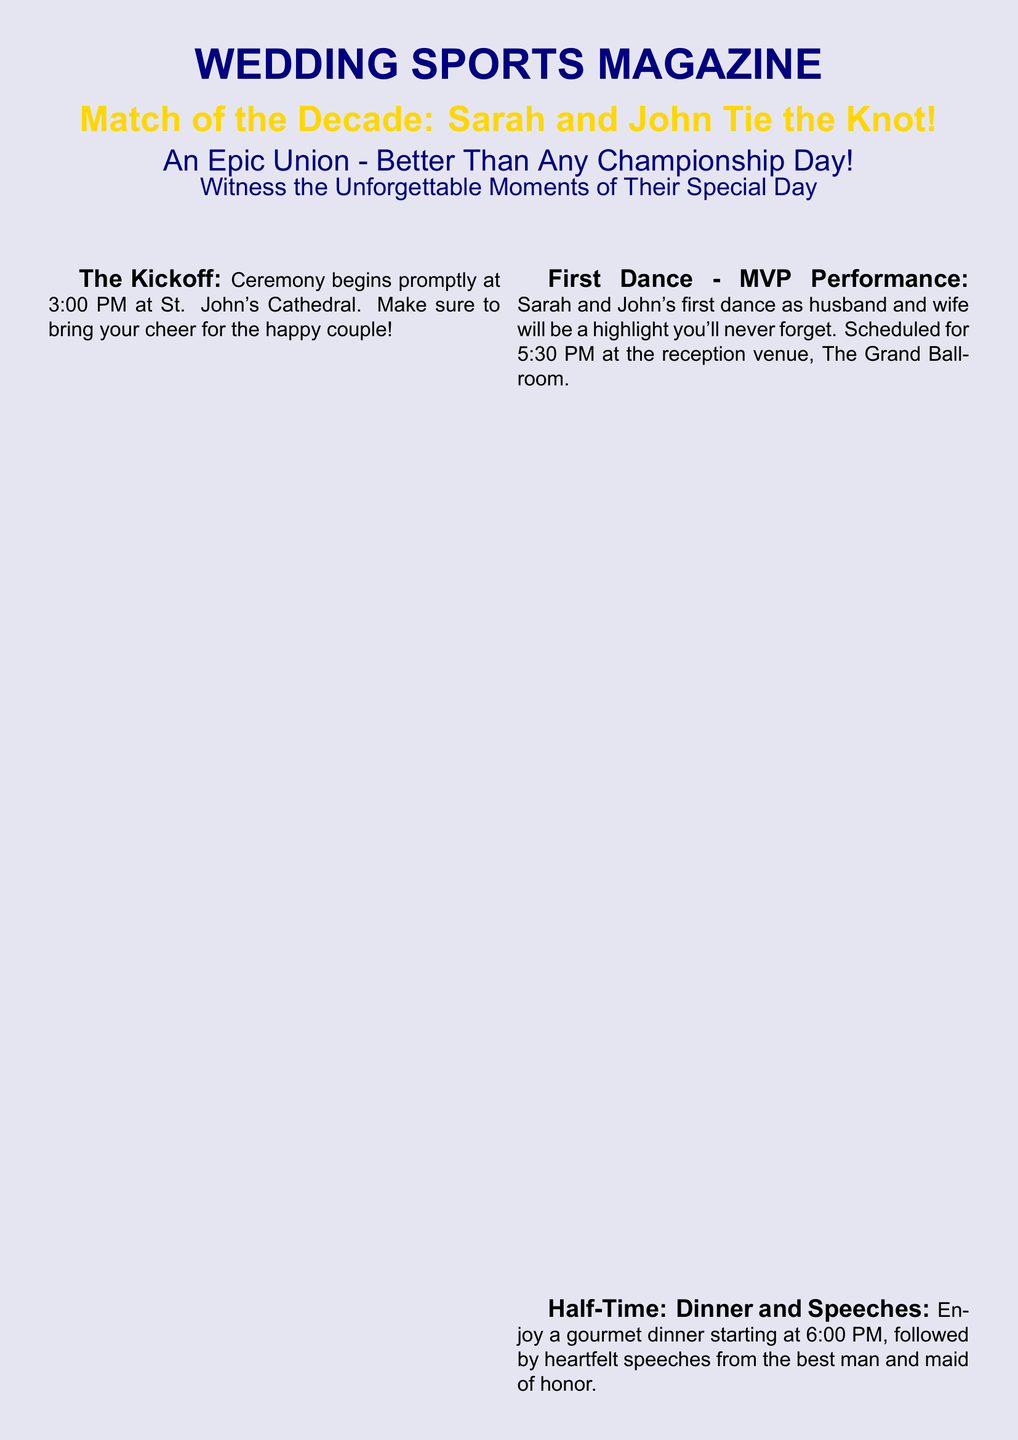What time does the ceremony start? The ceremony starts at 3:00 PM, as specified in the document.
Answer: 3:00 PM Who will officiate the ceremony? The officiant for the ceremony is mentioned as Pastor Michael Thompson.
Answer: Pastor Michael Thompson What color scheme should guests wear? The dress code encourages guests to wear shades of blue and gold to support the couple.
Answer: Blue and gold When is the first dance scheduled? The first dance is scheduled for 5:30 PM at the reception venue.
Answer: 5:30 PM What happens at 7:30 PM? The document states that Sarah will toss the bouquet and John will retrieve the garter at that time.
Answer: Bouquet toss and garter retrieval What is the purpose of the photobooth? The photobooth is available to capture favorite moments with the newlyweds throughout the evening.
Answer: Capture favorite moments How long does the dance party last? The dance party starts at 8:00 PM and ends at 11:00 PM, lasting for three hours.
Answer: 11:00 PM What is stated about the Orlando Pride? The document humorously declares that the celebration will not mention the Orlando Pride.
Answer: No mentions of the Orlando Pride allowed 